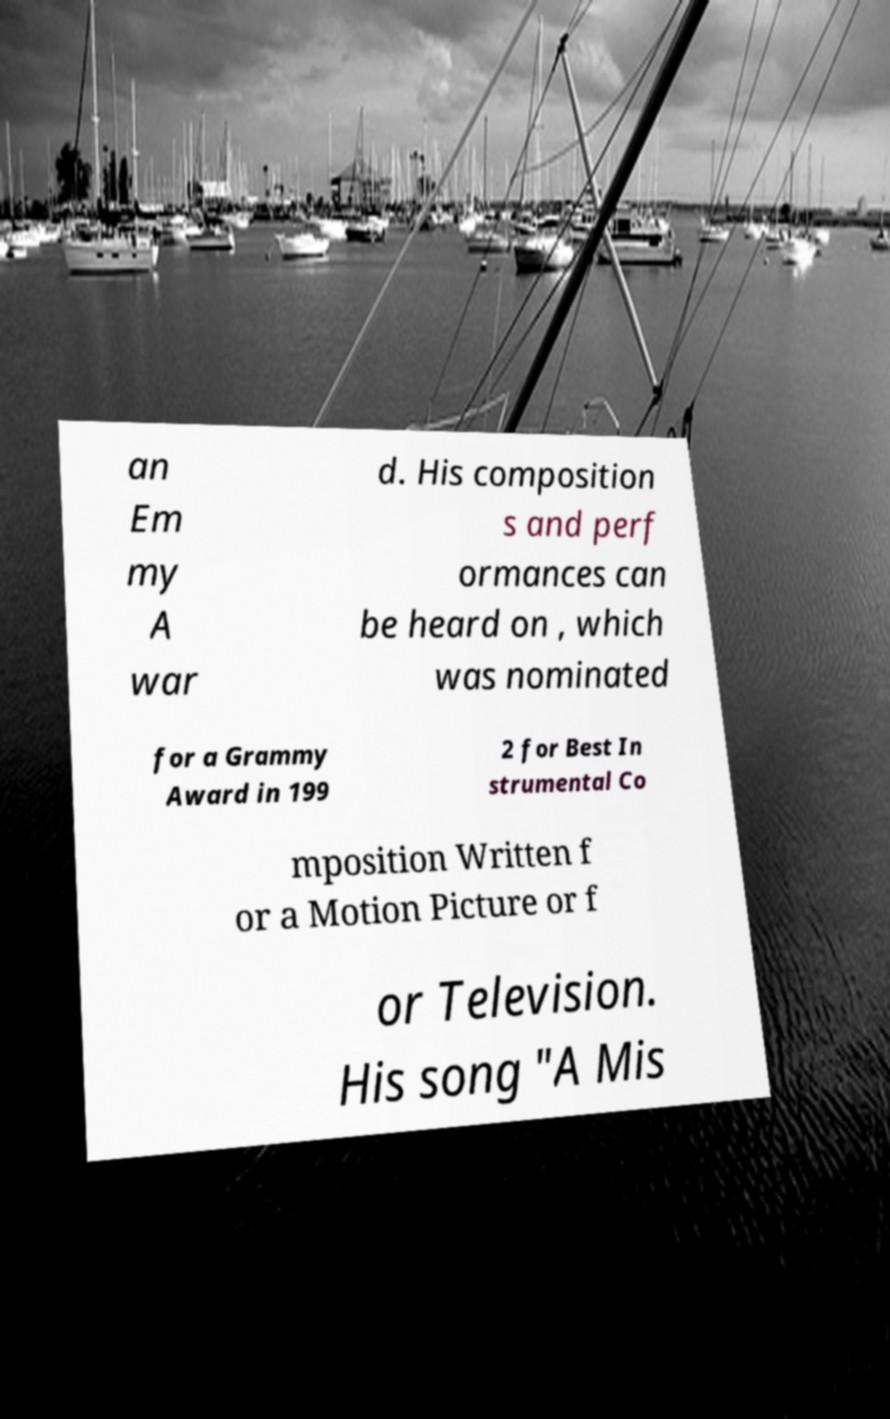Could you assist in decoding the text presented in this image and type it out clearly? an Em my A war d. His composition s and perf ormances can be heard on , which was nominated for a Grammy Award in 199 2 for Best In strumental Co mposition Written f or a Motion Picture or f or Television. His song "A Mis 